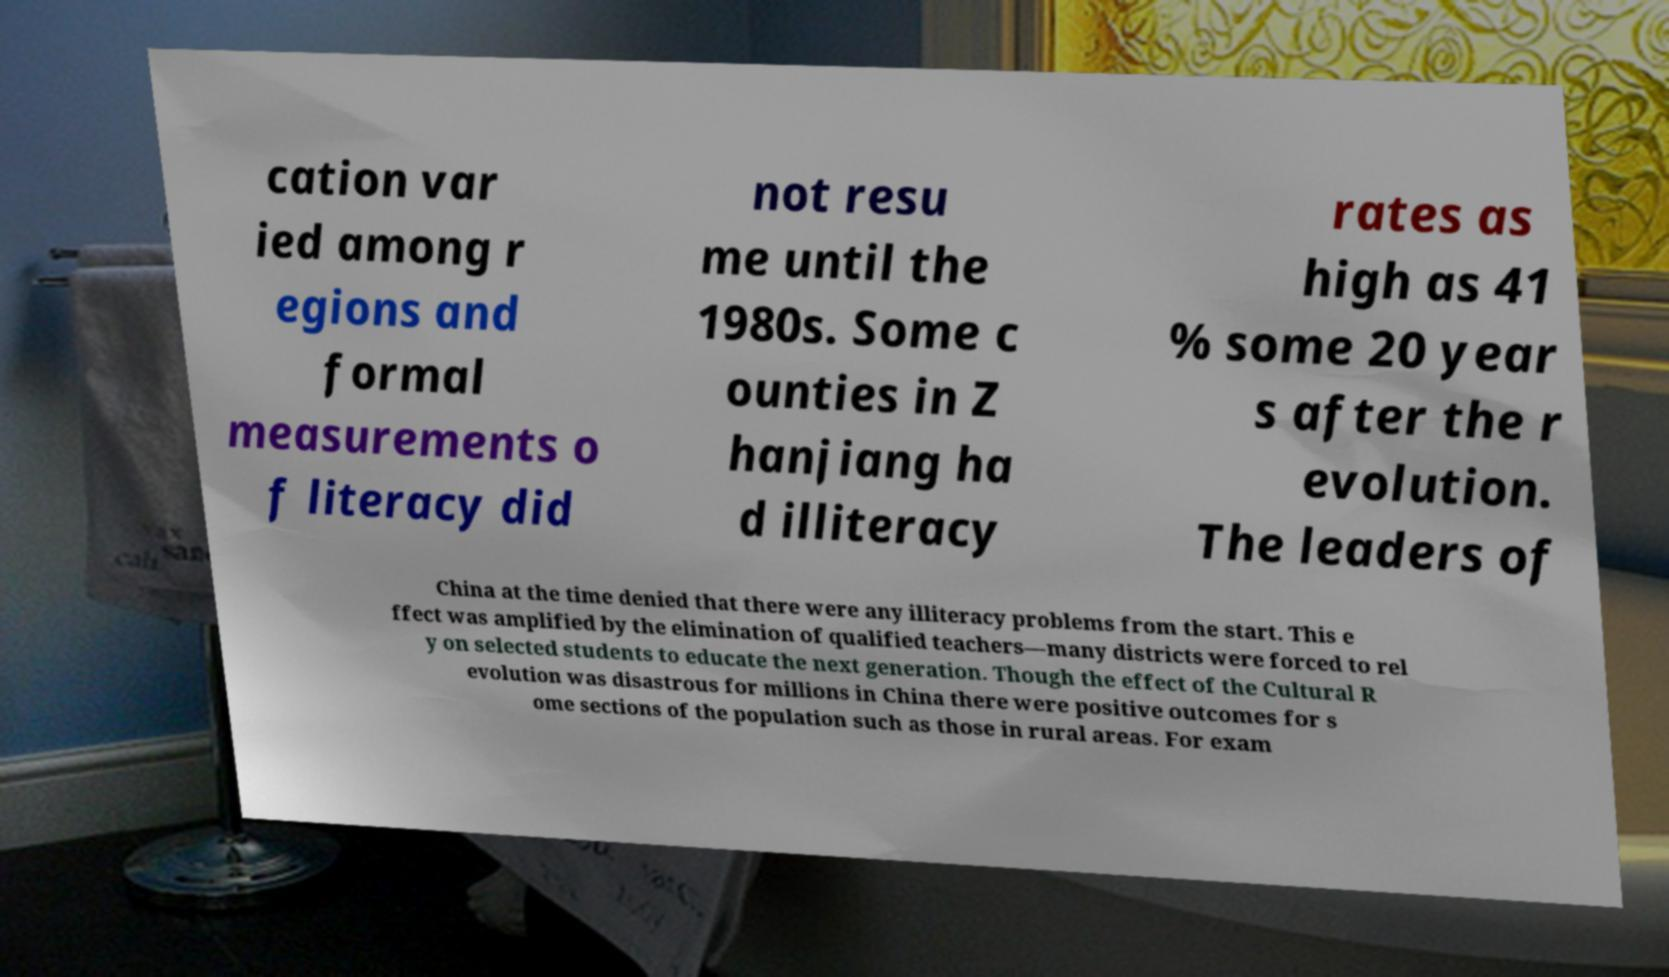For documentation purposes, I need the text within this image transcribed. Could you provide that? cation var ied among r egions and formal measurements o f literacy did not resu me until the 1980s. Some c ounties in Z hanjiang ha d illiteracy rates as high as 41 % some 20 year s after the r evolution. The leaders of China at the time denied that there were any illiteracy problems from the start. This e ffect was amplified by the elimination of qualified teachers—many districts were forced to rel y on selected students to educate the next generation. Though the effect of the Cultural R evolution was disastrous for millions in China there were positive outcomes for s ome sections of the population such as those in rural areas. For exam 